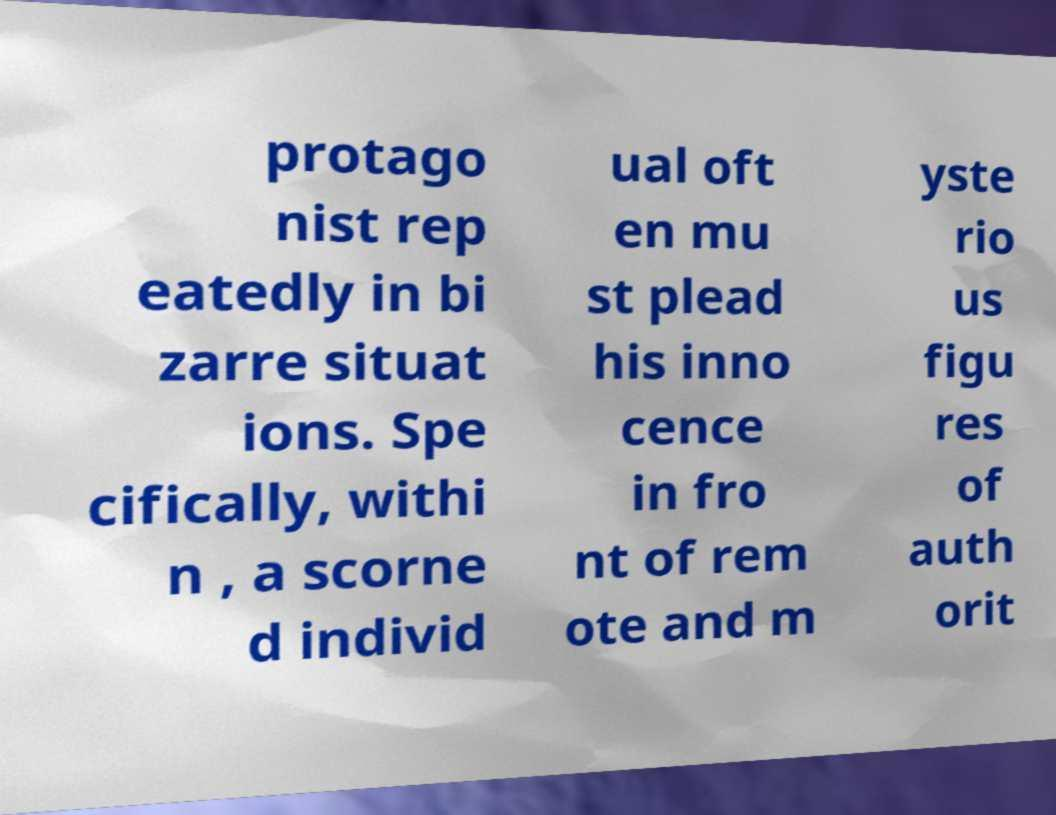Please read and relay the text visible in this image. What does it say? protago nist rep eatedly in bi zarre situat ions. Spe cifically, withi n , a scorne d individ ual oft en mu st plead his inno cence in fro nt of rem ote and m yste rio us figu res of auth orit 